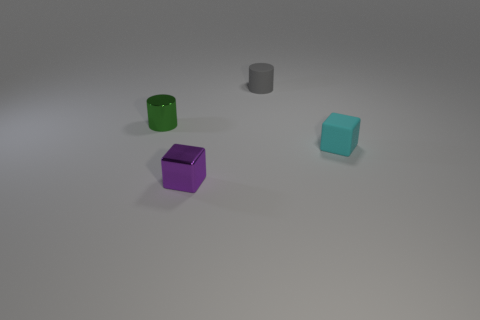There is a object that is both behind the purple block and left of the tiny gray cylinder; how big is it?
Make the answer very short. Small. What color is the thing that is both behind the tiny cyan rubber object and in front of the rubber cylinder?
Make the answer very short. Green. Is the number of purple metal cubes behind the small green metal object less than the number of cylinders in front of the gray rubber cylinder?
Ensure brevity in your answer.  Yes. How many tiny purple metal things have the same shape as the tiny cyan rubber thing?
Make the answer very short. 1. There is a cylinder that is the same material as the purple object; what is its size?
Offer a very short reply. Small. The cylinder to the right of the block that is to the left of the gray cylinder is what color?
Give a very brief answer. Gray. Do the green shiny thing and the purple object in front of the green cylinder have the same shape?
Offer a very short reply. No. How many cylinders have the same size as the rubber cube?
Make the answer very short. 2. There is a small green thing that is the same shape as the gray thing; what material is it?
Ensure brevity in your answer.  Metal. There is a thing that is in front of the cyan rubber cube; is it the same color as the small matte object behind the green shiny cylinder?
Your answer should be very brief. No. 